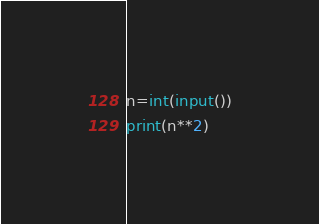Convert code to text. <code><loc_0><loc_0><loc_500><loc_500><_Python_>n=int(input())
print(n**2)</code> 